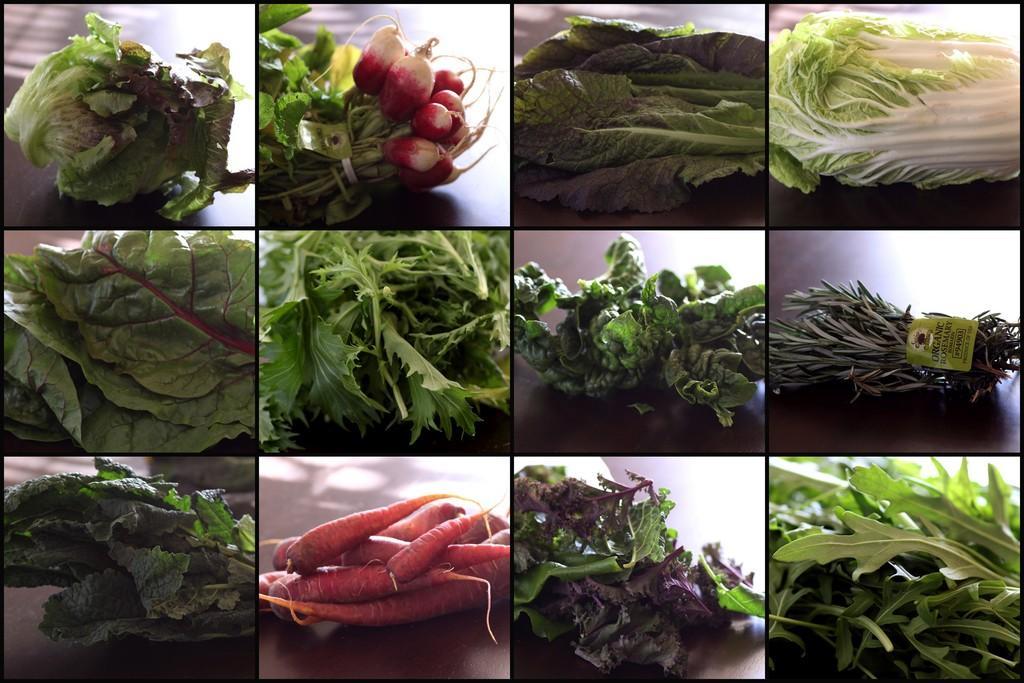Could you give a brief overview of what you see in this image? Here we can see a collage edited image and there are images of vegetables where we can see leafy vegetables and vegetables. 